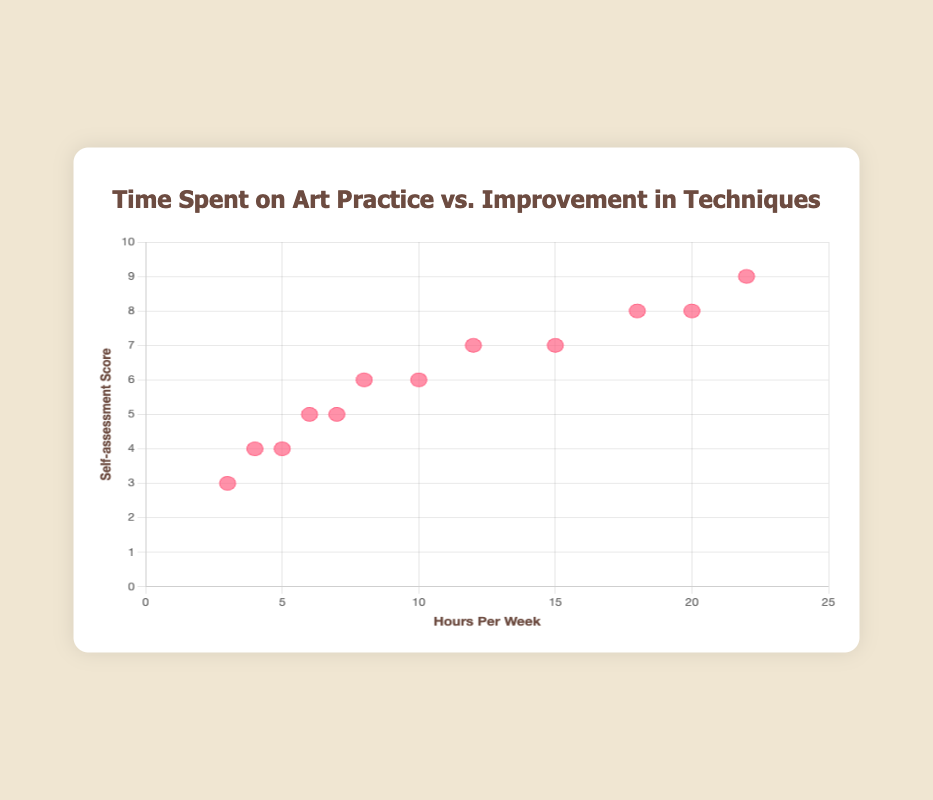What is the title of the scatter plot? The title can be found at the top center of the figure, indicating what the scatter plot is about.
Answer: Time Spent on Art Practice vs. Improvement in Techniques What do the x-axis and y-axis represent? The x-axis and y-axis represent two different variables. The x-axis label indicates it measures the 'Hours Per Week' spent on art practice, while the y-axis label shows it measures 'Self-assessment Score' for improvement in techniques.
Answer: x-axis: Hours Per Week, y-axis: Self-assessment Score How many data points are plotted in the scatter plot? Each data point corresponds to an artist, and by counting the points, we can see there are twelve data points.
Answer: Twelve Who spends the most time on art practice, and what is their self-assessment score? Look for the data point with the highest x-value, representing the highest hours per week. The tooltip shows the artist and their corresponding score. Prakash Tamang spends 22 hours and has a score of 9.
Answer: Prakash Tamang, 9 Which artist has the lowest self-assessment score, and how many hours do they practice per week? Look for the data point with the lowest y-value. The tooltip identifies the artist and their practice hours. Meena Rai has the lowest score of 3, practicing for 3 hours per week.
Answer: Meena Rai, 3 Is there a generally positive relationship between hours spent on practice and self-assessment scores? Observe the trend of the plotted points from lower left to upper right to infer the relationship. The data points generally show that as hours increase, scores tend to be higher, indicating a positive relationship.
Answer: Yes What is the average self-assessment score for artists who practice more than 10 hours per week? Identify the data points where hours per week are greater than 10 and calculate their average score. Artists: Karma Sherpa, Ramesh Thapa, Binod Maharjan, Amit Khadka, Prakash Tamang. (7 + 8 + 7 + 8 + 9) / 5 = 39 / 5 = 7.8
Answer: 7.8 How many artists have a self-assessment score of 6? Count the data points where the y-value (self-assessment score) is 6. There are two such data points for Sabita Gurung and Sita Magar.
Answer: Two Which two artists spend exactly 8 hours per week on art practice, and what are their self-assessment scores? Look for the data points where the x-value (hours per week) is 8. The tooltips show the artists and their scores: Sita Magar has a score of 6 and the other artist practicing 8 hours does not exist.
Answer: Sita Magar, 6 What is the self-assessment score for artists who practice for 5, 7, and 22 hours per week? We need the self-assessment scores for corresponding hours. Nirajan Shrestha (5 hours, score 4), Kalpana Lama (7 hours, score 5), Prakash Tamang (22 hours, score 9).
Answer: 4, 5, 9 